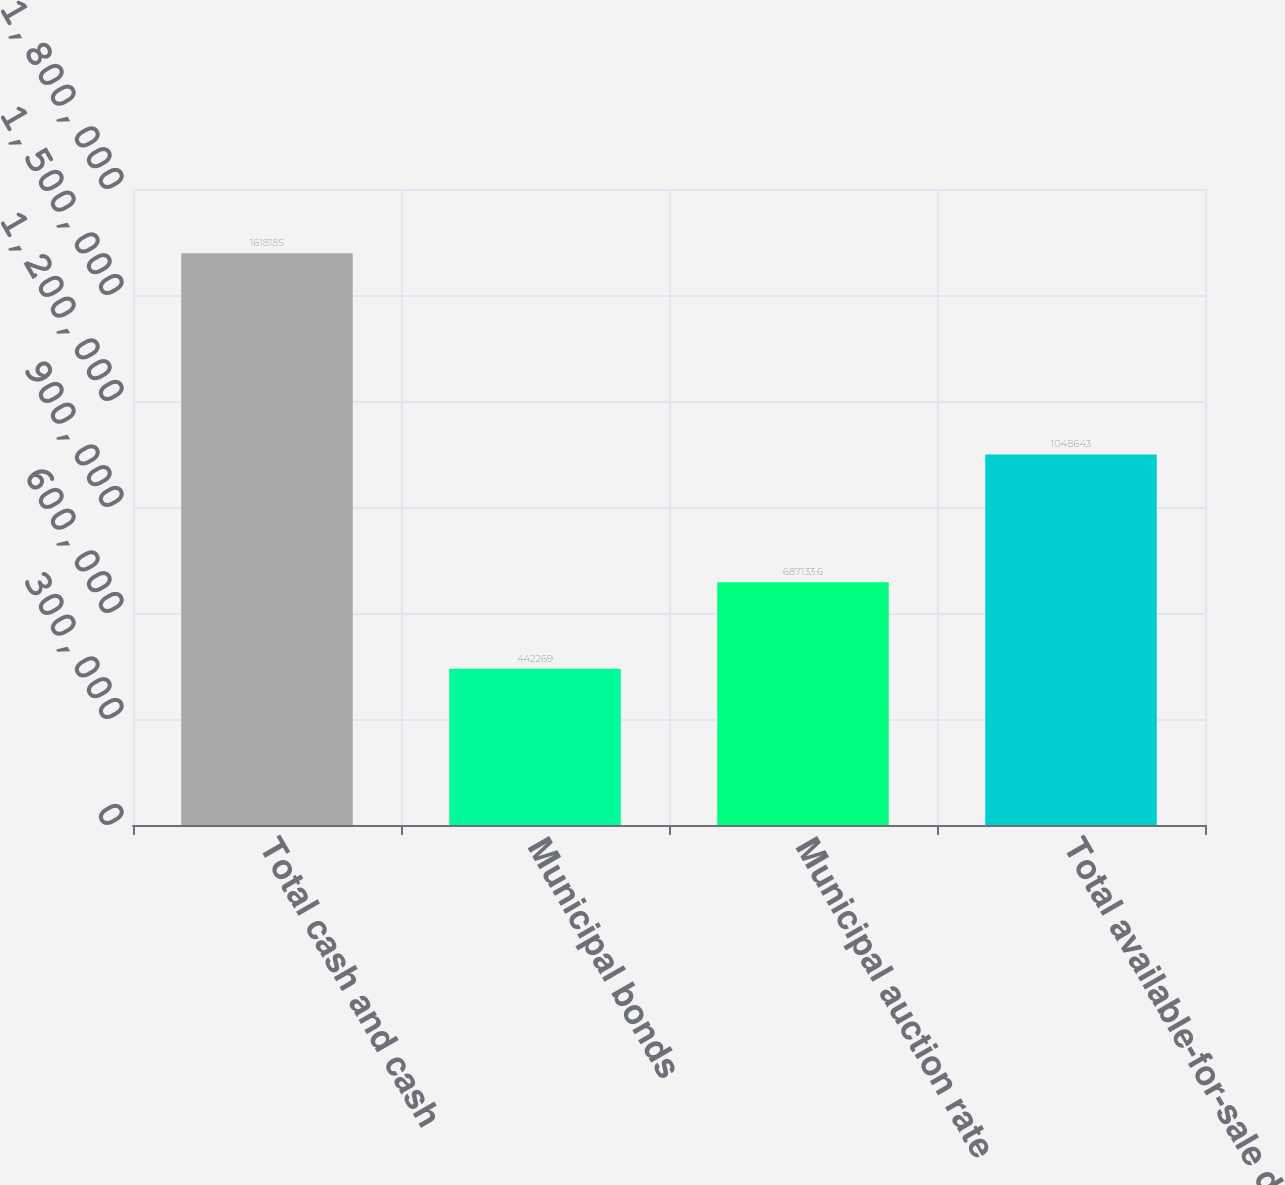Convert chart. <chart><loc_0><loc_0><loc_500><loc_500><bar_chart><fcel>Total cash and cash<fcel>Municipal bonds<fcel>Municipal auction rate<fcel>Total available-for-sale debt<nl><fcel>1.61818e+06<fcel>442269<fcel>687134<fcel>1.04864e+06<nl></chart> 